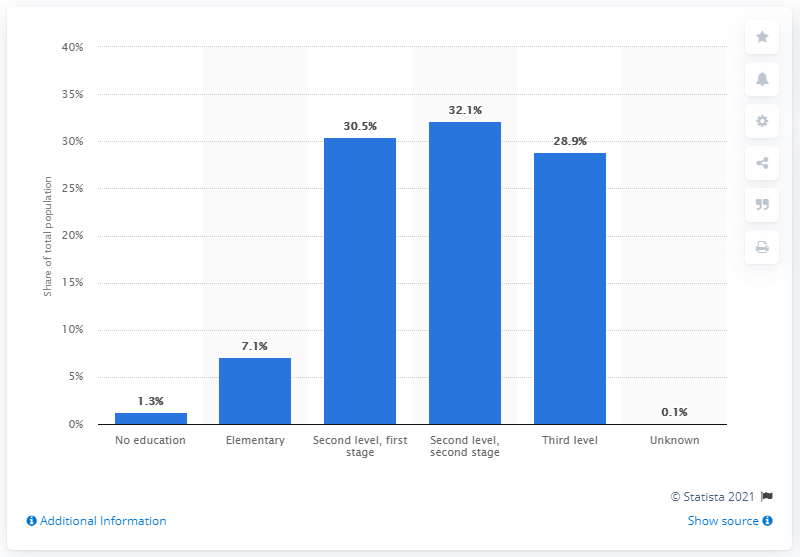Indicate a few pertinent items in this graphic. According to data from 2017, approximately 1.3% of the population of Curaao did not have a degree. 